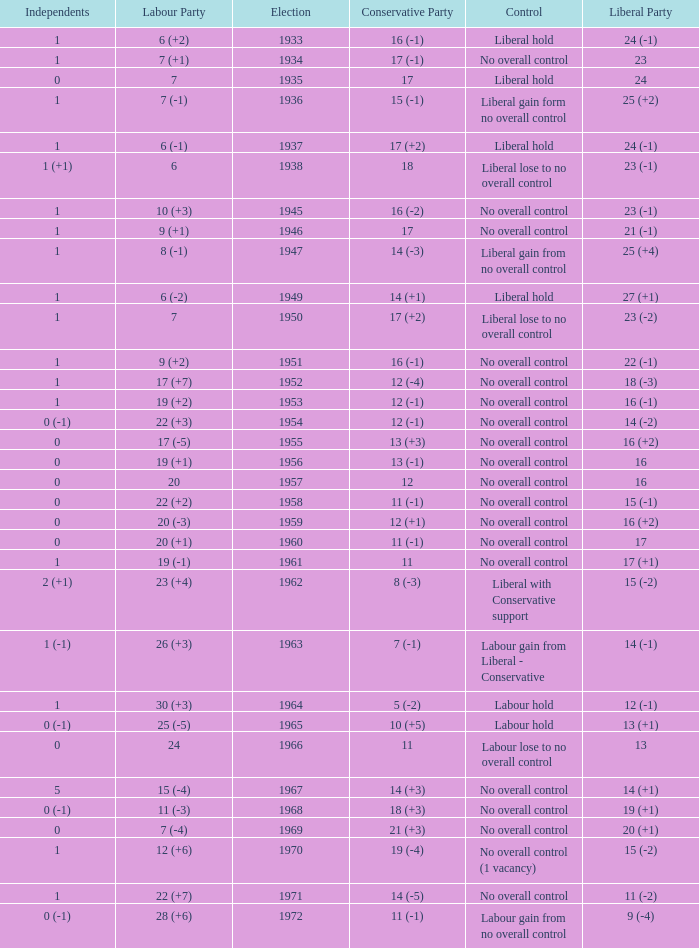Can you parse all the data within this table? {'header': ['Independents', 'Labour Party', 'Election', 'Conservative Party', 'Control', 'Liberal Party'], 'rows': [['1', '6 (+2)', '1933', '16 (-1)', 'Liberal hold', '24 (-1)'], ['1', '7 (+1)', '1934', '17 (-1)', 'No overall control', '23'], ['0', '7', '1935', '17', 'Liberal hold', '24'], ['1', '7 (-1)', '1936', '15 (-1)', 'Liberal gain form no overall control', '25 (+2)'], ['1', '6 (-1)', '1937', '17 (+2)', 'Liberal hold', '24 (-1)'], ['1 (+1)', '6', '1938', '18', 'Liberal lose to no overall control', '23 (-1)'], ['1', '10 (+3)', '1945', '16 (-2)', 'No overall control', '23 (-1)'], ['1', '9 (+1)', '1946', '17', 'No overall control', '21 (-1)'], ['1', '8 (-1)', '1947', '14 (-3)', 'Liberal gain from no overall control', '25 (+4)'], ['1', '6 (-2)', '1949', '14 (+1)', 'Liberal hold', '27 (+1)'], ['1', '7', '1950', '17 (+2)', 'Liberal lose to no overall control', '23 (-2)'], ['1', '9 (+2)', '1951', '16 (-1)', 'No overall control', '22 (-1)'], ['1', '17 (+7)', '1952', '12 (-4)', 'No overall control', '18 (-3)'], ['1', '19 (+2)', '1953', '12 (-1)', 'No overall control', '16 (-1)'], ['0 (-1)', '22 (+3)', '1954', '12 (-1)', 'No overall control', '14 (-2)'], ['0', '17 (-5)', '1955', '13 (+3)', 'No overall control', '16 (+2)'], ['0', '19 (+1)', '1956', '13 (-1)', 'No overall control', '16'], ['0', '20', '1957', '12', 'No overall control', '16'], ['0', '22 (+2)', '1958', '11 (-1)', 'No overall control', '15 (-1)'], ['0', '20 (-3)', '1959', '12 (+1)', 'No overall control', '16 (+2)'], ['0', '20 (+1)', '1960', '11 (-1)', 'No overall control', '17'], ['1', '19 (-1)', '1961', '11', 'No overall control', '17 (+1)'], ['2 (+1)', '23 (+4)', '1962', '8 (-3)', 'Liberal with Conservative support', '15 (-2)'], ['1 (-1)', '26 (+3)', '1963', '7 (-1)', 'Labour gain from Liberal - Conservative', '14 (-1)'], ['1', '30 (+3)', '1964', '5 (-2)', 'Labour hold', '12 (-1)'], ['0 (-1)', '25 (-5)', '1965', '10 (+5)', 'Labour hold', '13 (+1)'], ['0', '24', '1966', '11', 'Labour lose to no overall control', '13'], ['5', '15 (-4)', '1967', '14 (+3)', 'No overall control', '14 (+1)'], ['0 (-1)', '11 (-3)', '1968', '18 (+3)', 'No overall control', '19 (+1)'], ['0', '7 (-4)', '1969', '21 (+3)', 'No overall control', '20 (+1)'], ['1', '12 (+6)', '1970', '19 (-4)', 'No overall control (1 vacancy)', '15 (-2)'], ['1', '22 (+7)', '1971', '14 (-5)', 'No overall control', '11 (-2)'], ['0 (-1)', '28 (+6)', '1972', '11 (-1)', 'Labour gain from no overall control', '9 (-4)']]} Who was in control the year that Labour Party won 12 (+6) seats? No overall control (1 vacancy). 